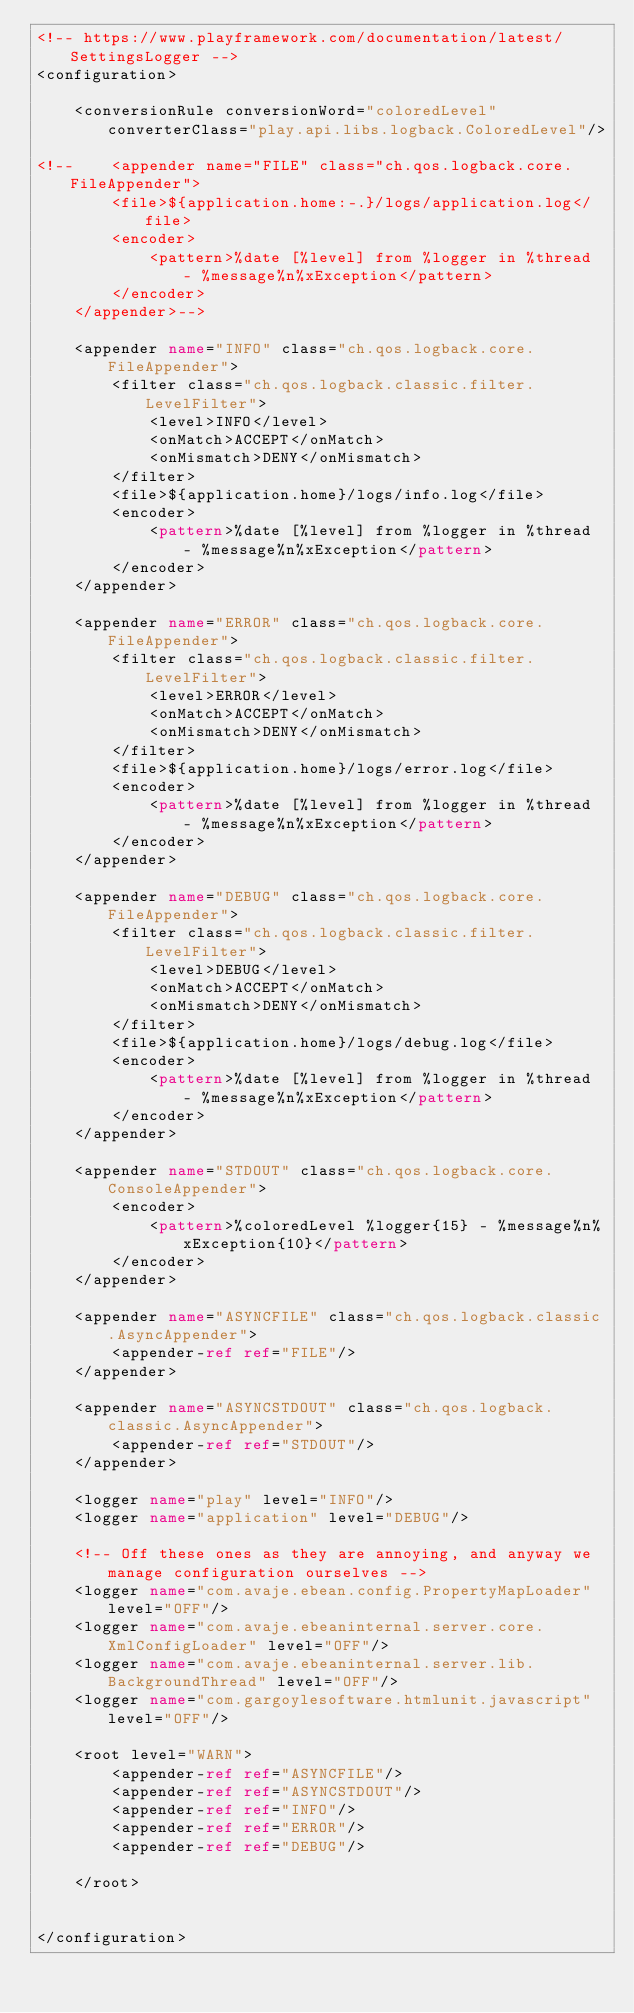Convert code to text. <code><loc_0><loc_0><loc_500><loc_500><_XML_><!-- https://www.playframework.com/documentation/latest/SettingsLogger -->
<configuration>

    <conversionRule conversionWord="coloredLevel" converterClass="play.api.libs.logback.ColoredLevel"/>

<!--    <appender name="FILE" class="ch.qos.logback.core.FileAppender">
        <file>${application.home:-.}/logs/application.log</file>
        <encoder>
            <pattern>%date [%level] from %logger in %thread - %message%n%xException</pattern>
        </encoder>
    </appender>-->

    <appender name="INFO" class="ch.qos.logback.core.FileAppender">
        <filter class="ch.qos.logback.classic.filter.LevelFilter">
            <level>INFO</level>
            <onMatch>ACCEPT</onMatch>
            <onMismatch>DENY</onMismatch>
        </filter>
        <file>${application.home}/logs/info.log</file>
        <encoder>
            <pattern>%date [%level] from %logger in %thread - %message%n%xException</pattern>
        </encoder>
    </appender>

    <appender name="ERROR" class="ch.qos.logback.core.FileAppender">
        <filter class="ch.qos.logback.classic.filter.LevelFilter">
            <level>ERROR</level>
            <onMatch>ACCEPT</onMatch>
            <onMismatch>DENY</onMismatch>
        </filter>
        <file>${application.home}/logs/error.log</file>
        <encoder>
            <pattern>%date [%level] from %logger in %thread - %message%n%xException</pattern>
        </encoder>
    </appender>

    <appender name="DEBUG" class="ch.qos.logback.core.FileAppender">
        <filter class="ch.qos.logback.classic.filter.LevelFilter">
            <level>DEBUG</level>
            <onMatch>ACCEPT</onMatch>
            <onMismatch>DENY</onMismatch>
        </filter>
        <file>${application.home}/logs/debug.log</file>
        <encoder>
            <pattern>%date [%level] from %logger in %thread - %message%n%xException</pattern>
        </encoder>
    </appender>

    <appender name="STDOUT" class="ch.qos.logback.core.ConsoleAppender">
        <encoder>
            <pattern>%coloredLevel %logger{15} - %message%n%xException{10}</pattern>
        </encoder>
    </appender>

    <appender name="ASYNCFILE" class="ch.qos.logback.classic.AsyncAppender">
        <appender-ref ref="FILE"/>
    </appender>

    <appender name="ASYNCSTDOUT" class="ch.qos.logback.classic.AsyncAppender">
        <appender-ref ref="STDOUT"/>
    </appender>

    <logger name="play" level="INFO"/>
    <logger name="application" level="DEBUG"/>

    <!-- Off these ones as they are annoying, and anyway we manage configuration ourselves -->
    <logger name="com.avaje.ebean.config.PropertyMapLoader" level="OFF"/>
    <logger name="com.avaje.ebeaninternal.server.core.XmlConfigLoader" level="OFF"/>
    <logger name="com.avaje.ebeaninternal.server.lib.BackgroundThread" level="OFF"/>
    <logger name="com.gargoylesoftware.htmlunit.javascript" level="OFF"/>

    <root level="WARN">
        <appender-ref ref="ASYNCFILE"/>
        <appender-ref ref="ASYNCSTDOUT"/>
        <appender-ref ref="INFO"/>
        <appender-ref ref="ERROR"/>
        <appender-ref ref="DEBUG"/>

    </root>


</configuration>
</code> 